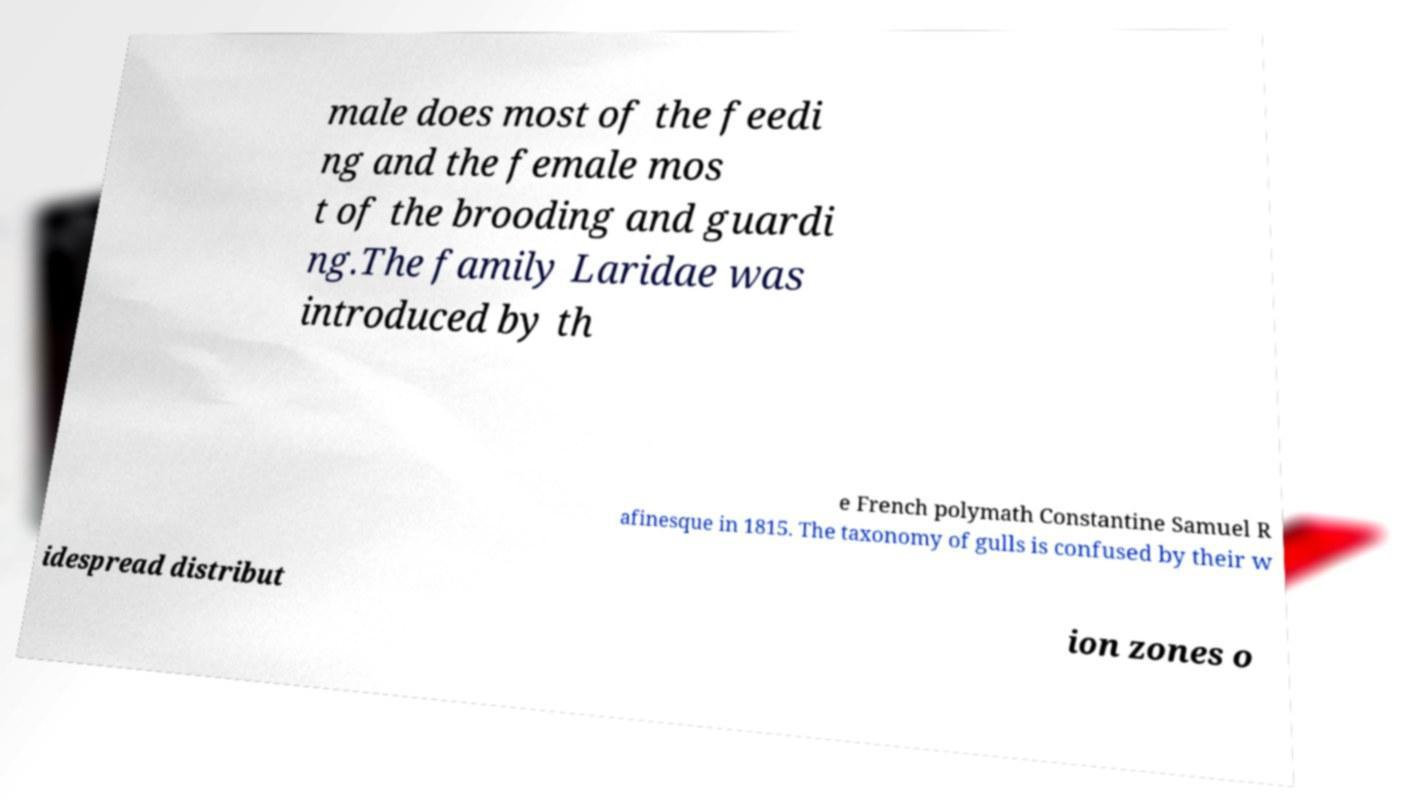Please read and relay the text visible in this image. What does it say? male does most of the feedi ng and the female mos t of the brooding and guardi ng.The family Laridae was introduced by th e French polymath Constantine Samuel R afinesque in 1815. The taxonomy of gulls is confused by their w idespread distribut ion zones o 